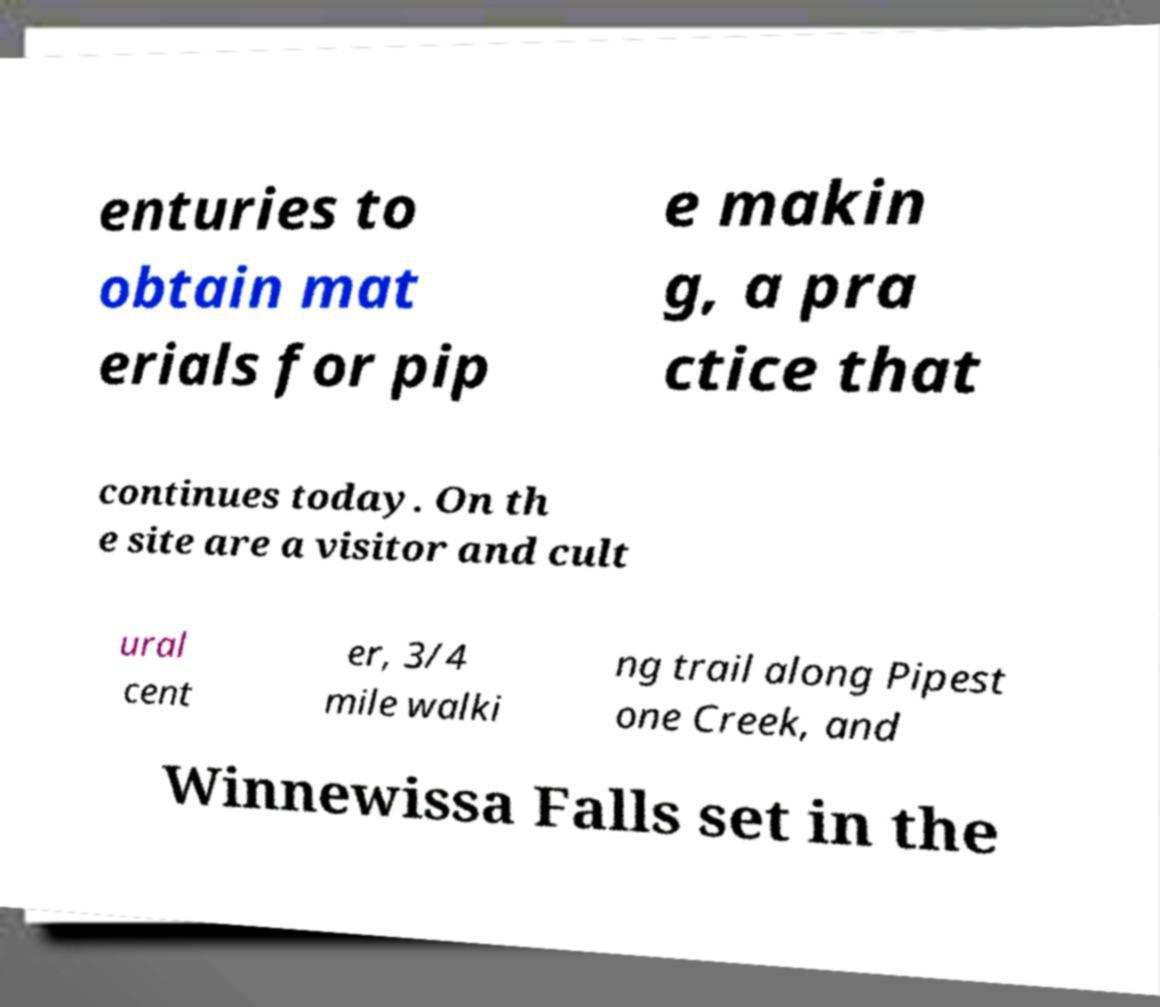Can you read and provide the text displayed in the image?This photo seems to have some interesting text. Can you extract and type it out for me? enturies to obtain mat erials for pip e makin g, a pra ctice that continues today. On th e site are a visitor and cult ural cent er, 3/4 mile walki ng trail along Pipest one Creek, and Winnewissa Falls set in the 